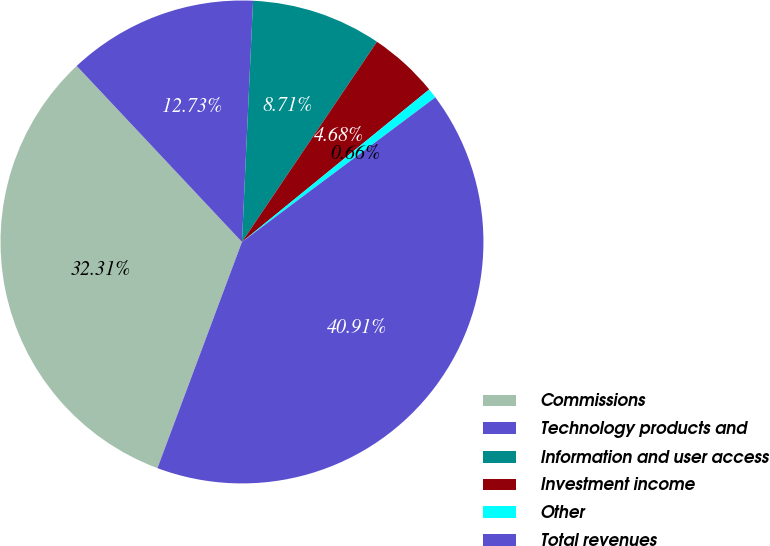Convert chart to OTSL. <chart><loc_0><loc_0><loc_500><loc_500><pie_chart><fcel>Commissions<fcel>Technology products and<fcel>Information and user access<fcel>Investment income<fcel>Other<fcel>Total revenues<nl><fcel>32.31%<fcel>12.73%<fcel>8.71%<fcel>4.68%<fcel>0.66%<fcel>40.91%<nl></chart> 